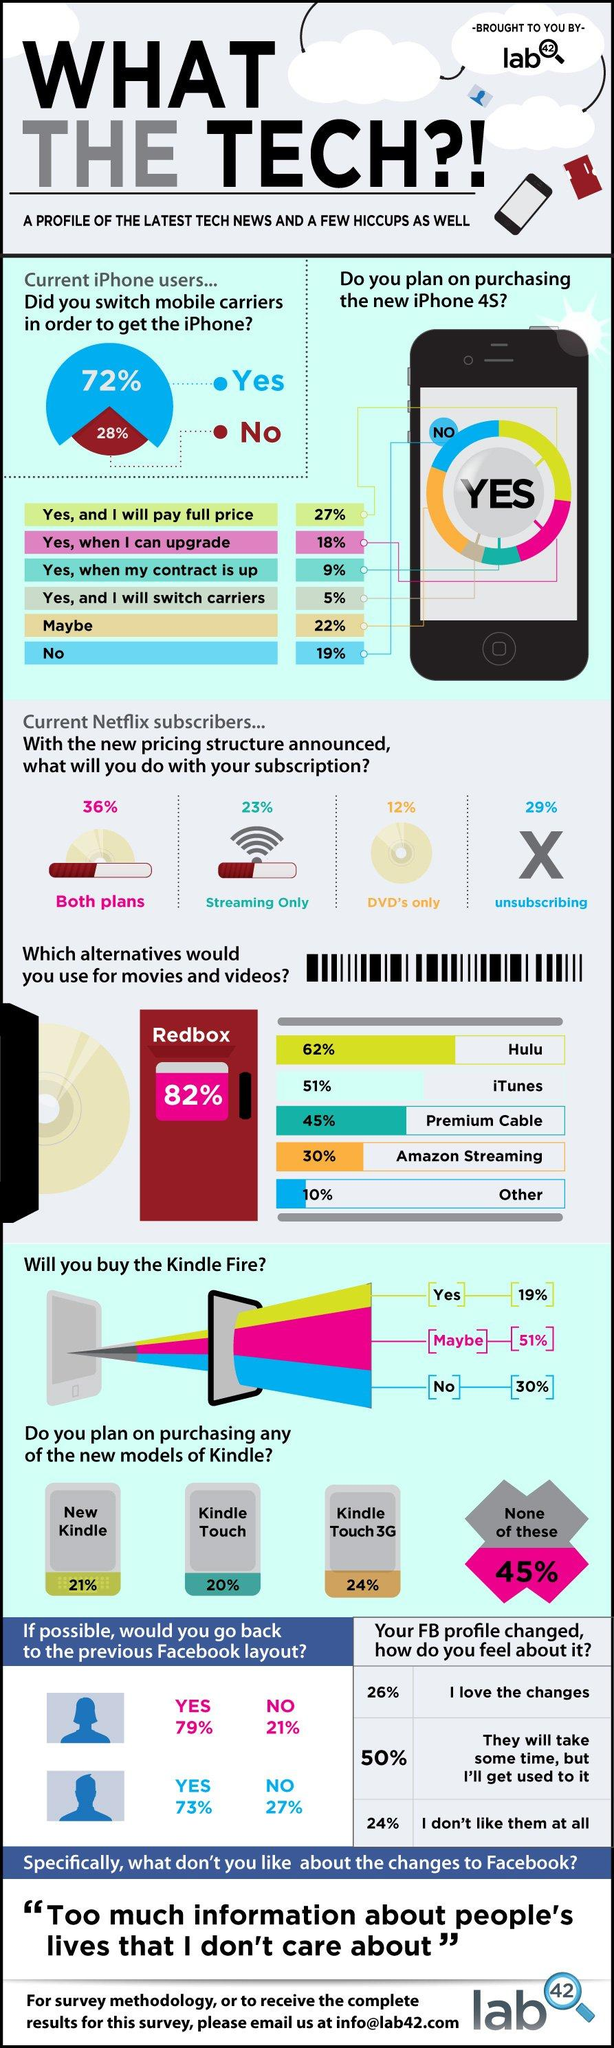Highlight a few significant elements in this photo. The survey found that the majority of respondents use Redbox as an alternative to watch movies and videos. According to the survey, 20% of respondents plan to buy a Kindle Touch. According to the survey, 30% of respondents reported using Amazon streaming as an alternative to watch movies and videos. According to recent data, 23% of current Netflix subscribers only stream content with their subscription. Approximately 19% of current iPhone users have no intention of purchasing the new iPhone 4S, according to the survey. 